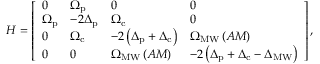<formula> <loc_0><loc_0><loc_500><loc_500>H = \left [ \begin{array} { l l l l } { 0 } & { \Omega _ { p } } & { 0 } & { 0 } \\ { \Omega _ { p } } & { - 2 \Delta _ { p } } & { \Omega _ { c } } & { 0 } \\ { 0 } & { \Omega _ { c } } & { - 2 \left ( \Delta _ { p } + \Delta _ { c } \right ) } & { \Omega _ { M W } \left ( A M \right ) } \\ { 0 } & { 0 } & { \Omega _ { M W } \left ( A M \right ) } & { - 2 \left ( \Delta _ { p } + \Delta _ { c } - \Delta _ { M W } \right ) } \end{array} \right ] ,</formula> 